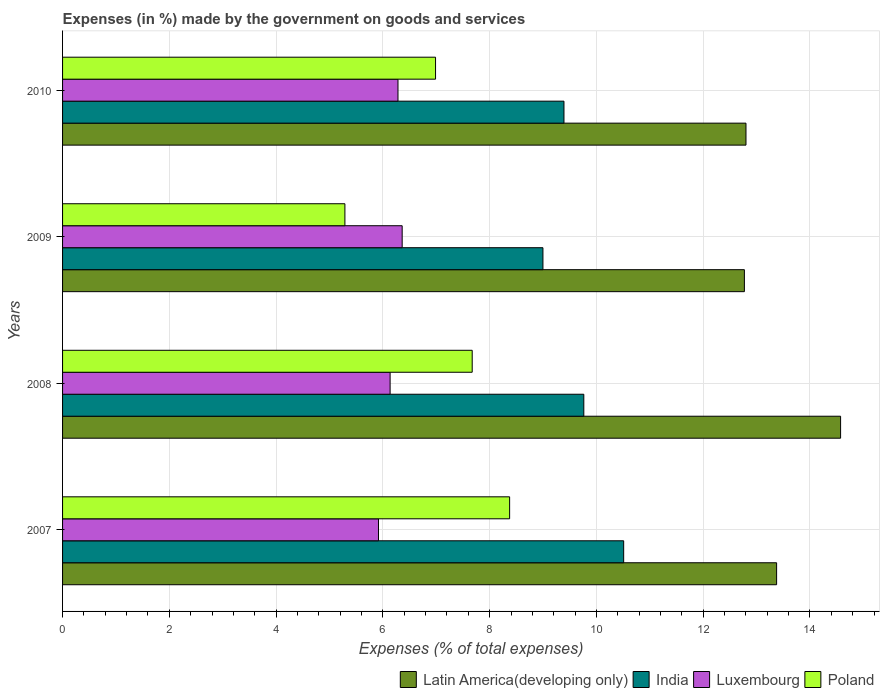How many groups of bars are there?
Your response must be concise. 4. Are the number of bars per tick equal to the number of legend labels?
Offer a terse response. Yes. Are the number of bars on each tick of the Y-axis equal?
Give a very brief answer. Yes. What is the label of the 2nd group of bars from the top?
Ensure brevity in your answer.  2009. What is the percentage of expenses made by the government on goods and services in Luxembourg in 2009?
Offer a terse response. 6.36. Across all years, what is the maximum percentage of expenses made by the government on goods and services in Luxembourg?
Your answer should be very brief. 6.36. Across all years, what is the minimum percentage of expenses made by the government on goods and services in Latin America(developing only)?
Offer a terse response. 12.77. In which year was the percentage of expenses made by the government on goods and services in India maximum?
Offer a very short reply. 2007. In which year was the percentage of expenses made by the government on goods and services in Luxembourg minimum?
Give a very brief answer. 2007. What is the total percentage of expenses made by the government on goods and services in Latin America(developing only) in the graph?
Your answer should be very brief. 53.52. What is the difference between the percentage of expenses made by the government on goods and services in Poland in 2008 and that in 2009?
Offer a very short reply. 2.38. What is the difference between the percentage of expenses made by the government on goods and services in Luxembourg in 2009 and the percentage of expenses made by the government on goods and services in India in 2008?
Your answer should be compact. -3.4. What is the average percentage of expenses made by the government on goods and services in Luxembourg per year?
Your answer should be compact. 6.17. In the year 2010, what is the difference between the percentage of expenses made by the government on goods and services in Latin America(developing only) and percentage of expenses made by the government on goods and services in Poland?
Make the answer very short. 5.82. What is the ratio of the percentage of expenses made by the government on goods and services in Poland in 2007 to that in 2010?
Keep it short and to the point. 1.2. Is the percentage of expenses made by the government on goods and services in Luxembourg in 2007 less than that in 2008?
Provide a short and direct response. Yes. What is the difference between the highest and the second highest percentage of expenses made by the government on goods and services in Latin America(developing only)?
Provide a succinct answer. 1.2. What is the difference between the highest and the lowest percentage of expenses made by the government on goods and services in India?
Make the answer very short. 1.51. Is the sum of the percentage of expenses made by the government on goods and services in Luxembourg in 2008 and 2010 greater than the maximum percentage of expenses made by the government on goods and services in India across all years?
Keep it short and to the point. Yes. What does the 1st bar from the top in 2007 represents?
Keep it short and to the point. Poland. What does the 4th bar from the bottom in 2008 represents?
Offer a very short reply. Poland. How many bars are there?
Provide a succinct answer. 16. Does the graph contain any zero values?
Provide a short and direct response. No. Does the graph contain grids?
Make the answer very short. Yes. How are the legend labels stacked?
Provide a short and direct response. Horizontal. What is the title of the graph?
Offer a very short reply. Expenses (in %) made by the government on goods and services. Does "Middle income" appear as one of the legend labels in the graph?
Provide a succinct answer. No. What is the label or title of the X-axis?
Your answer should be very brief. Expenses (% of total expenses). What is the label or title of the Y-axis?
Provide a succinct answer. Years. What is the Expenses (% of total expenses) of Latin America(developing only) in 2007?
Give a very brief answer. 13.38. What is the Expenses (% of total expenses) in India in 2007?
Offer a very short reply. 10.51. What is the Expenses (% of total expenses) of Luxembourg in 2007?
Give a very brief answer. 5.92. What is the Expenses (% of total expenses) of Poland in 2007?
Offer a very short reply. 8.37. What is the Expenses (% of total expenses) in Latin America(developing only) in 2008?
Keep it short and to the point. 14.57. What is the Expenses (% of total expenses) in India in 2008?
Your answer should be compact. 9.76. What is the Expenses (% of total expenses) of Luxembourg in 2008?
Offer a very short reply. 6.14. What is the Expenses (% of total expenses) in Poland in 2008?
Keep it short and to the point. 7.67. What is the Expenses (% of total expenses) in Latin America(developing only) in 2009?
Ensure brevity in your answer.  12.77. What is the Expenses (% of total expenses) of India in 2009?
Your answer should be compact. 9. What is the Expenses (% of total expenses) of Luxembourg in 2009?
Offer a terse response. 6.36. What is the Expenses (% of total expenses) of Poland in 2009?
Offer a very short reply. 5.29. What is the Expenses (% of total expenses) of Latin America(developing only) in 2010?
Ensure brevity in your answer.  12.8. What is the Expenses (% of total expenses) of India in 2010?
Provide a short and direct response. 9.39. What is the Expenses (% of total expenses) in Luxembourg in 2010?
Offer a very short reply. 6.28. What is the Expenses (% of total expenses) of Poland in 2010?
Offer a terse response. 6.99. Across all years, what is the maximum Expenses (% of total expenses) in Latin America(developing only)?
Your answer should be compact. 14.57. Across all years, what is the maximum Expenses (% of total expenses) of India?
Keep it short and to the point. 10.51. Across all years, what is the maximum Expenses (% of total expenses) in Luxembourg?
Keep it short and to the point. 6.36. Across all years, what is the maximum Expenses (% of total expenses) of Poland?
Offer a very short reply. 8.37. Across all years, what is the minimum Expenses (% of total expenses) in Latin America(developing only)?
Offer a very short reply. 12.77. Across all years, what is the minimum Expenses (% of total expenses) of India?
Ensure brevity in your answer.  9. Across all years, what is the minimum Expenses (% of total expenses) of Luxembourg?
Your answer should be compact. 5.92. Across all years, what is the minimum Expenses (% of total expenses) of Poland?
Make the answer very short. 5.29. What is the total Expenses (% of total expenses) in Latin America(developing only) in the graph?
Keep it short and to the point. 53.52. What is the total Expenses (% of total expenses) in India in the graph?
Offer a very short reply. 38.66. What is the total Expenses (% of total expenses) in Luxembourg in the graph?
Your response must be concise. 24.7. What is the total Expenses (% of total expenses) of Poland in the graph?
Provide a succinct answer. 28.32. What is the difference between the Expenses (% of total expenses) in Latin America(developing only) in 2007 and that in 2008?
Offer a very short reply. -1.2. What is the difference between the Expenses (% of total expenses) of India in 2007 and that in 2008?
Your answer should be very brief. 0.75. What is the difference between the Expenses (% of total expenses) in Luxembourg in 2007 and that in 2008?
Your response must be concise. -0.22. What is the difference between the Expenses (% of total expenses) of Poland in 2007 and that in 2008?
Offer a terse response. 0.7. What is the difference between the Expenses (% of total expenses) in Latin America(developing only) in 2007 and that in 2009?
Give a very brief answer. 0.6. What is the difference between the Expenses (% of total expenses) in India in 2007 and that in 2009?
Your answer should be very brief. 1.51. What is the difference between the Expenses (% of total expenses) of Luxembourg in 2007 and that in 2009?
Your answer should be very brief. -0.44. What is the difference between the Expenses (% of total expenses) of Poland in 2007 and that in 2009?
Keep it short and to the point. 3.09. What is the difference between the Expenses (% of total expenses) in Latin America(developing only) in 2007 and that in 2010?
Make the answer very short. 0.57. What is the difference between the Expenses (% of total expenses) of India in 2007 and that in 2010?
Keep it short and to the point. 1.12. What is the difference between the Expenses (% of total expenses) in Luxembourg in 2007 and that in 2010?
Provide a succinct answer. -0.37. What is the difference between the Expenses (% of total expenses) in Poland in 2007 and that in 2010?
Your response must be concise. 1.39. What is the difference between the Expenses (% of total expenses) in Latin America(developing only) in 2008 and that in 2009?
Keep it short and to the point. 1.8. What is the difference between the Expenses (% of total expenses) of India in 2008 and that in 2009?
Offer a very short reply. 0.77. What is the difference between the Expenses (% of total expenses) of Luxembourg in 2008 and that in 2009?
Keep it short and to the point. -0.23. What is the difference between the Expenses (% of total expenses) of Poland in 2008 and that in 2009?
Provide a succinct answer. 2.38. What is the difference between the Expenses (% of total expenses) in Latin America(developing only) in 2008 and that in 2010?
Your answer should be very brief. 1.77. What is the difference between the Expenses (% of total expenses) in India in 2008 and that in 2010?
Offer a very short reply. 0.37. What is the difference between the Expenses (% of total expenses) in Luxembourg in 2008 and that in 2010?
Ensure brevity in your answer.  -0.15. What is the difference between the Expenses (% of total expenses) in Poland in 2008 and that in 2010?
Make the answer very short. 0.69. What is the difference between the Expenses (% of total expenses) of Latin America(developing only) in 2009 and that in 2010?
Your response must be concise. -0.03. What is the difference between the Expenses (% of total expenses) in India in 2009 and that in 2010?
Your response must be concise. -0.39. What is the difference between the Expenses (% of total expenses) of Luxembourg in 2009 and that in 2010?
Provide a succinct answer. 0.08. What is the difference between the Expenses (% of total expenses) of Poland in 2009 and that in 2010?
Provide a short and direct response. -1.7. What is the difference between the Expenses (% of total expenses) in Latin America(developing only) in 2007 and the Expenses (% of total expenses) in India in 2008?
Give a very brief answer. 3.61. What is the difference between the Expenses (% of total expenses) of Latin America(developing only) in 2007 and the Expenses (% of total expenses) of Luxembourg in 2008?
Offer a terse response. 7.24. What is the difference between the Expenses (% of total expenses) of Latin America(developing only) in 2007 and the Expenses (% of total expenses) of Poland in 2008?
Give a very brief answer. 5.7. What is the difference between the Expenses (% of total expenses) of India in 2007 and the Expenses (% of total expenses) of Luxembourg in 2008?
Give a very brief answer. 4.38. What is the difference between the Expenses (% of total expenses) of India in 2007 and the Expenses (% of total expenses) of Poland in 2008?
Your answer should be very brief. 2.84. What is the difference between the Expenses (% of total expenses) of Luxembourg in 2007 and the Expenses (% of total expenses) of Poland in 2008?
Ensure brevity in your answer.  -1.76. What is the difference between the Expenses (% of total expenses) of Latin America(developing only) in 2007 and the Expenses (% of total expenses) of India in 2009?
Provide a succinct answer. 4.38. What is the difference between the Expenses (% of total expenses) of Latin America(developing only) in 2007 and the Expenses (% of total expenses) of Luxembourg in 2009?
Ensure brevity in your answer.  7.01. What is the difference between the Expenses (% of total expenses) in Latin America(developing only) in 2007 and the Expenses (% of total expenses) in Poland in 2009?
Offer a terse response. 8.09. What is the difference between the Expenses (% of total expenses) in India in 2007 and the Expenses (% of total expenses) in Luxembourg in 2009?
Keep it short and to the point. 4.15. What is the difference between the Expenses (% of total expenses) of India in 2007 and the Expenses (% of total expenses) of Poland in 2009?
Your answer should be very brief. 5.22. What is the difference between the Expenses (% of total expenses) of Luxembourg in 2007 and the Expenses (% of total expenses) of Poland in 2009?
Provide a succinct answer. 0.63. What is the difference between the Expenses (% of total expenses) in Latin America(developing only) in 2007 and the Expenses (% of total expenses) in India in 2010?
Make the answer very short. 3.98. What is the difference between the Expenses (% of total expenses) in Latin America(developing only) in 2007 and the Expenses (% of total expenses) in Luxembourg in 2010?
Your answer should be compact. 7.09. What is the difference between the Expenses (% of total expenses) in Latin America(developing only) in 2007 and the Expenses (% of total expenses) in Poland in 2010?
Provide a succinct answer. 6.39. What is the difference between the Expenses (% of total expenses) of India in 2007 and the Expenses (% of total expenses) of Luxembourg in 2010?
Give a very brief answer. 4.23. What is the difference between the Expenses (% of total expenses) of India in 2007 and the Expenses (% of total expenses) of Poland in 2010?
Offer a terse response. 3.52. What is the difference between the Expenses (% of total expenses) of Luxembourg in 2007 and the Expenses (% of total expenses) of Poland in 2010?
Your response must be concise. -1.07. What is the difference between the Expenses (% of total expenses) of Latin America(developing only) in 2008 and the Expenses (% of total expenses) of India in 2009?
Your answer should be very brief. 5.58. What is the difference between the Expenses (% of total expenses) of Latin America(developing only) in 2008 and the Expenses (% of total expenses) of Luxembourg in 2009?
Provide a short and direct response. 8.21. What is the difference between the Expenses (% of total expenses) in Latin America(developing only) in 2008 and the Expenses (% of total expenses) in Poland in 2009?
Provide a succinct answer. 9.29. What is the difference between the Expenses (% of total expenses) of India in 2008 and the Expenses (% of total expenses) of Luxembourg in 2009?
Provide a short and direct response. 3.4. What is the difference between the Expenses (% of total expenses) of India in 2008 and the Expenses (% of total expenses) of Poland in 2009?
Your answer should be compact. 4.48. What is the difference between the Expenses (% of total expenses) of Luxembourg in 2008 and the Expenses (% of total expenses) of Poland in 2009?
Keep it short and to the point. 0.85. What is the difference between the Expenses (% of total expenses) in Latin America(developing only) in 2008 and the Expenses (% of total expenses) in India in 2010?
Your answer should be very brief. 5.18. What is the difference between the Expenses (% of total expenses) in Latin America(developing only) in 2008 and the Expenses (% of total expenses) in Luxembourg in 2010?
Your answer should be compact. 8.29. What is the difference between the Expenses (% of total expenses) of Latin America(developing only) in 2008 and the Expenses (% of total expenses) of Poland in 2010?
Keep it short and to the point. 7.59. What is the difference between the Expenses (% of total expenses) of India in 2008 and the Expenses (% of total expenses) of Luxembourg in 2010?
Ensure brevity in your answer.  3.48. What is the difference between the Expenses (% of total expenses) of India in 2008 and the Expenses (% of total expenses) of Poland in 2010?
Offer a very short reply. 2.78. What is the difference between the Expenses (% of total expenses) of Luxembourg in 2008 and the Expenses (% of total expenses) of Poland in 2010?
Offer a terse response. -0.85. What is the difference between the Expenses (% of total expenses) of Latin America(developing only) in 2009 and the Expenses (% of total expenses) of India in 2010?
Your answer should be compact. 3.38. What is the difference between the Expenses (% of total expenses) in Latin America(developing only) in 2009 and the Expenses (% of total expenses) in Luxembourg in 2010?
Offer a very short reply. 6.49. What is the difference between the Expenses (% of total expenses) of Latin America(developing only) in 2009 and the Expenses (% of total expenses) of Poland in 2010?
Keep it short and to the point. 5.79. What is the difference between the Expenses (% of total expenses) in India in 2009 and the Expenses (% of total expenses) in Luxembourg in 2010?
Your answer should be compact. 2.72. What is the difference between the Expenses (% of total expenses) in India in 2009 and the Expenses (% of total expenses) in Poland in 2010?
Offer a terse response. 2.01. What is the difference between the Expenses (% of total expenses) of Luxembourg in 2009 and the Expenses (% of total expenses) of Poland in 2010?
Offer a terse response. -0.63. What is the average Expenses (% of total expenses) of Latin America(developing only) per year?
Offer a terse response. 13.38. What is the average Expenses (% of total expenses) in India per year?
Keep it short and to the point. 9.67. What is the average Expenses (% of total expenses) in Luxembourg per year?
Your answer should be compact. 6.17. What is the average Expenses (% of total expenses) in Poland per year?
Offer a very short reply. 7.08. In the year 2007, what is the difference between the Expenses (% of total expenses) in Latin America(developing only) and Expenses (% of total expenses) in India?
Make the answer very short. 2.86. In the year 2007, what is the difference between the Expenses (% of total expenses) of Latin America(developing only) and Expenses (% of total expenses) of Luxembourg?
Provide a succinct answer. 7.46. In the year 2007, what is the difference between the Expenses (% of total expenses) in Latin America(developing only) and Expenses (% of total expenses) in Poland?
Offer a very short reply. 5. In the year 2007, what is the difference between the Expenses (% of total expenses) in India and Expenses (% of total expenses) in Luxembourg?
Ensure brevity in your answer.  4.59. In the year 2007, what is the difference between the Expenses (% of total expenses) in India and Expenses (% of total expenses) in Poland?
Provide a short and direct response. 2.14. In the year 2007, what is the difference between the Expenses (% of total expenses) of Luxembourg and Expenses (% of total expenses) of Poland?
Provide a short and direct response. -2.46. In the year 2008, what is the difference between the Expenses (% of total expenses) in Latin America(developing only) and Expenses (% of total expenses) in India?
Provide a short and direct response. 4.81. In the year 2008, what is the difference between the Expenses (% of total expenses) in Latin America(developing only) and Expenses (% of total expenses) in Luxembourg?
Your response must be concise. 8.44. In the year 2008, what is the difference between the Expenses (% of total expenses) of Latin America(developing only) and Expenses (% of total expenses) of Poland?
Your answer should be very brief. 6.9. In the year 2008, what is the difference between the Expenses (% of total expenses) in India and Expenses (% of total expenses) in Luxembourg?
Your answer should be compact. 3.63. In the year 2008, what is the difference between the Expenses (% of total expenses) in India and Expenses (% of total expenses) in Poland?
Your answer should be compact. 2.09. In the year 2008, what is the difference between the Expenses (% of total expenses) of Luxembourg and Expenses (% of total expenses) of Poland?
Provide a succinct answer. -1.54. In the year 2009, what is the difference between the Expenses (% of total expenses) in Latin America(developing only) and Expenses (% of total expenses) in India?
Your answer should be very brief. 3.77. In the year 2009, what is the difference between the Expenses (% of total expenses) of Latin America(developing only) and Expenses (% of total expenses) of Luxembourg?
Provide a short and direct response. 6.41. In the year 2009, what is the difference between the Expenses (% of total expenses) in Latin America(developing only) and Expenses (% of total expenses) in Poland?
Offer a terse response. 7.48. In the year 2009, what is the difference between the Expenses (% of total expenses) of India and Expenses (% of total expenses) of Luxembourg?
Give a very brief answer. 2.64. In the year 2009, what is the difference between the Expenses (% of total expenses) in India and Expenses (% of total expenses) in Poland?
Offer a very short reply. 3.71. In the year 2009, what is the difference between the Expenses (% of total expenses) of Luxembourg and Expenses (% of total expenses) of Poland?
Keep it short and to the point. 1.07. In the year 2010, what is the difference between the Expenses (% of total expenses) of Latin America(developing only) and Expenses (% of total expenses) of India?
Make the answer very short. 3.41. In the year 2010, what is the difference between the Expenses (% of total expenses) of Latin America(developing only) and Expenses (% of total expenses) of Luxembourg?
Provide a succinct answer. 6.52. In the year 2010, what is the difference between the Expenses (% of total expenses) of Latin America(developing only) and Expenses (% of total expenses) of Poland?
Offer a very short reply. 5.82. In the year 2010, what is the difference between the Expenses (% of total expenses) of India and Expenses (% of total expenses) of Luxembourg?
Offer a very short reply. 3.11. In the year 2010, what is the difference between the Expenses (% of total expenses) in India and Expenses (% of total expenses) in Poland?
Make the answer very short. 2.41. In the year 2010, what is the difference between the Expenses (% of total expenses) in Luxembourg and Expenses (% of total expenses) in Poland?
Provide a short and direct response. -0.7. What is the ratio of the Expenses (% of total expenses) in Latin America(developing only) in 2007 to that in 2008?
Ensure brevity in your answer.  0.92. What is the ratio of the Expenses (% of total expenses) of India in 2007 to that in 2008?
Your response must be concise. 1.08. What is the ratio of the Expenses (% of total expenses) in Luxembourg in 2007 to that in 2008?
Your response must be concise. 0.96. What is the ratio of the Expenses (% of total expenses) in Poland in 2007 to that in 2008?
Give a very brief answer. 1.09. What is the ratio of the Expenses (% of total expenses) of Latin America(developing only) in 2007 to that in 2009?
Make the answer very short. 1.05. What is the ratio of the Expenses (% of total expenses) in India in 2007 to that in 2009?
Offer a very short reply. 1.17. What is the ratio of the Expenses (% of total expenses) of Luxembourg in 2007 to that in 2009?
Give a very brief answer. 0.93. What is the ratio of the Expenses (% of total expenses) of Poland in 2007 to that in 2009?
Your response must be concise. 1.58. What is the ratio of the Expenses (% of total expenses) in Latin America(developing only) in 2007 to that in 2010?
Ensure brevity in your answer.  1.04. What is the ratio of the Expenses (% of total expenses) of India in 2007 to that in 2010?
Give a very brief answer. 1.12. What is the ratio of the Expenses (% of total expenses) of Luxembourg in 2007 to that in 2010?
Keep it short and to the point. 0.94. What is the ratio of the Expenses (% of total expenses) in Poland in 2007 to that in 2010?
Your answer should be very brief. 1.2. What is the ratio of the Expenses (% of total expenses) in Latin America(developing only) in 2008 to that in 2009?
Your response must be concise. 1.14. What is the ratio of the Expenses (% of total expenses) in India in 2008 to that in 2009?
Keep it short and to the point. 1.09. What is the ratio of the Expenses (% of total expenses) in Luxembourg in 2008 to that in 2009?
Provide a short and direct response. 0.96. What is the ratio of the Expenses (% of total expenses) in Poland in 2008 to that in 2009?
Keep it short and to the point. 1.45. What is the ratio of the Expenses (% of total expenses) of Latin America(developing only) in 2008 to that in 2010?
Ensure brevity in your answer.  1.14. What is the ratio of the Expenses (% of total expenses) of India in 2008 to that in 2010?
Provide a short and direct response. 1.04. What is the ratio of the Expenses (% of total expenses) in Luxembourg in 2008 to that in 2010?
Offer a very short reply. 0.98. What is the ratio of the Expenses (% of total expenses) in Poland in 2008 to that in 2010?
Your answer should be very brief. 1.1. What is the ratio of the Expenses (% of total expenses) of Latin America(developing only) in 2009 to that in 2010?
Provide a succinct answer. 1. What is the ratio of the Expenses (% of total expenses) in India in 2009 to that in 2010?
Your answer should be very brief. 0.96. What is the ratio of the Expenses (% of total expenses) of Luxembourg in 2009 to that in 2010?
Provide a short and direct response. 1.01. What is the ratio of the Expenses (% of total expenses) in Poland in 2009 to that in 2010?
Provide a succinct answer. 0.76. What is the difference between the highest and the second highest Expenses (% of total expenses) in Latin America(developing only)?
Provide a short and direct response. 1.2. What is the difference between the highest and the second highest Expenses (% of total expenses) of India?
Offer a very short reply. 0.75. What is the difference between the highest and the second highest Expenses (% of total expenses) of Luxembourg?
Keep it short and to the point. 0.08. What is the difference between the highest and the second highest Expenses (% of total expenses) in Poland?
Offer a terse response. 0.7. What is the difference between the highest and the lowest Expenses (% of total expenses) of Latin America(developing only)?
Offer a terse response. 1.8. What is the difference between the highest and the lowest Expenses (% of total expenses) in India?
Give a very brief answer. 1.51. What is the difference between the highest and the lowest Expenses (% of total expenses) of Luxembourg?
Your answer should be compact. 0.44. What is the difference between the highest and the lowest Expenses (% of total expenses) of Poland?
Make the answer very short. 3.09. 